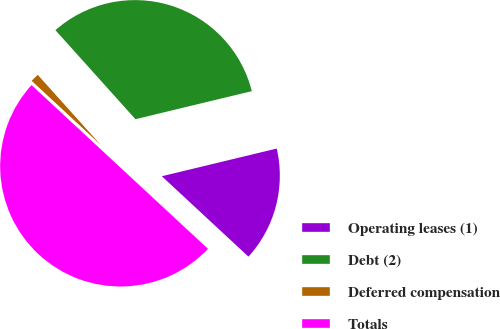Convert chart to OTSL. <chart><loc_0><loc_0><loc_500><loc_500><pie_chart><fcel>Operating leases (1)<fcel>Debt (2)<fcel>Deferred compensation<fcel>Totals<nl><fcel>15.67%<fcel>32.89%<fcel>1.44%<fcel>50.0%<nl></chart> 